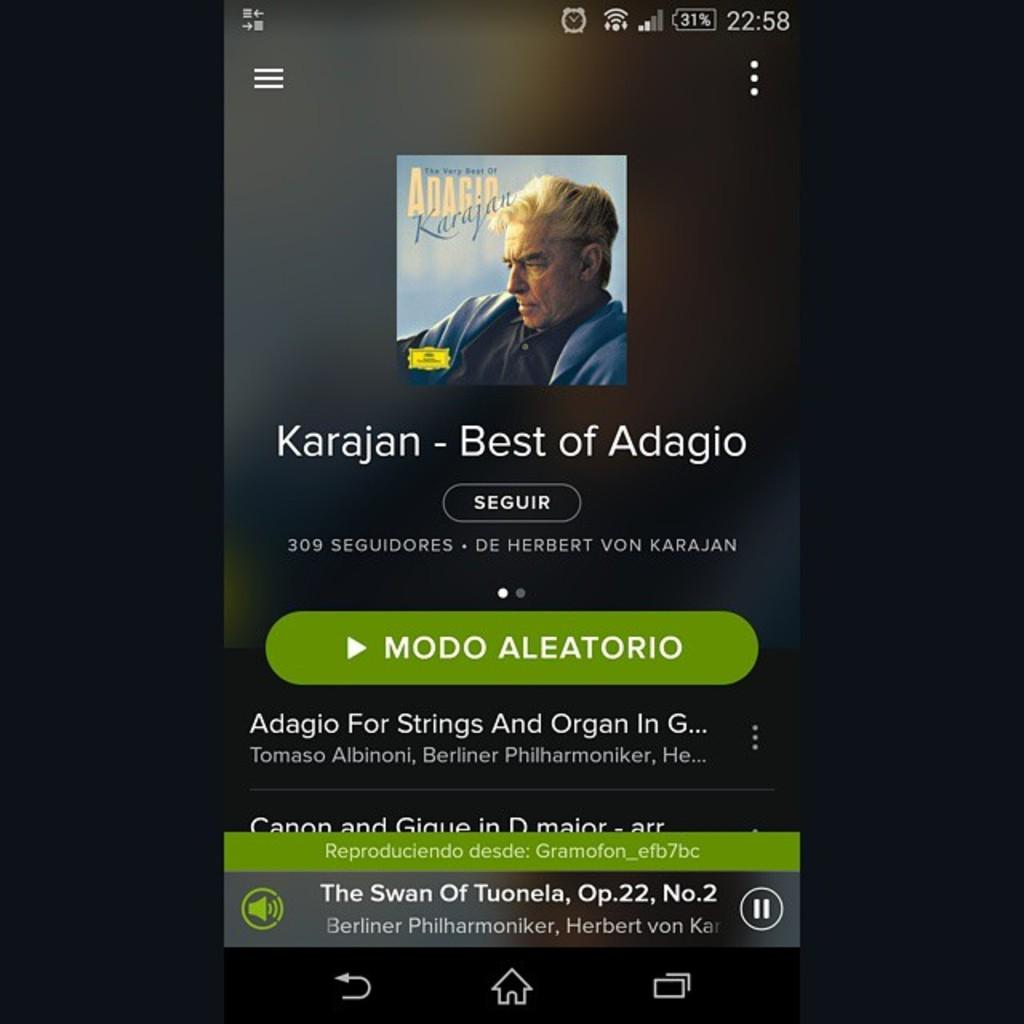Provide a one-sentence caption for the provided image. A poster advertising the Best of Adagio by Karajan. 